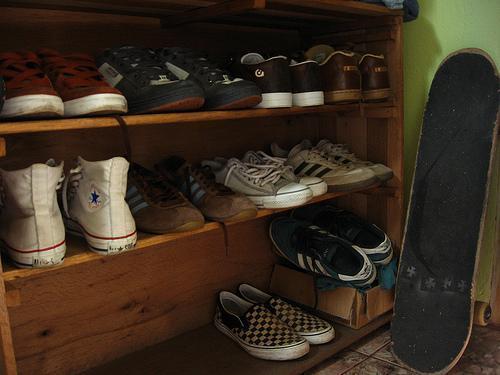How many pairs of shoes are there?
Give a very brief answer. 10. 